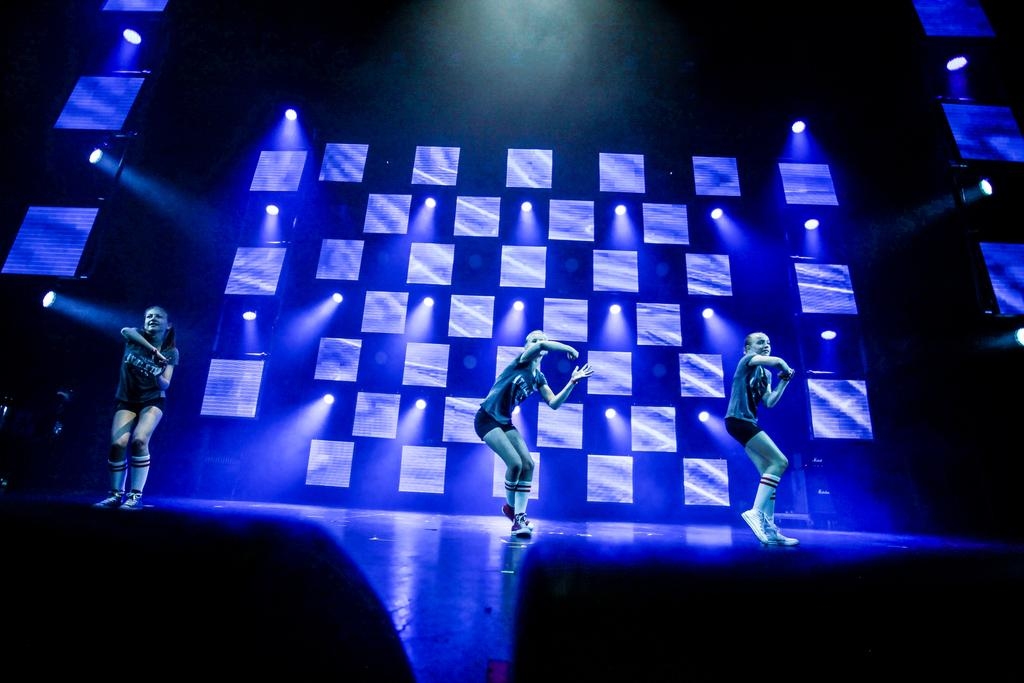How many people are in the image? There are three people in the image. What are the people doing in the image? The people are dancing on a stage. What can be seen in the background of the image? There is a wall visible in the image. What is special about the wall in the image? The wall has blue color lights. What type of toy can be seen in the hands of the people while they are dancing? There is no toy visible in the image; the people are dancing without any toys. What kind of bears are present in the image? There are no bears present in the image; the main subjects are three people dancing on a stage. 